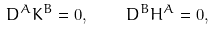Convert formula to latex. <formula><loc_0><loc_0><loc_500><loc_500>D ^ { A } K ^ { B } = 0 , \quad D ^ { B } H ^ { A } = 0 ,</formula> 